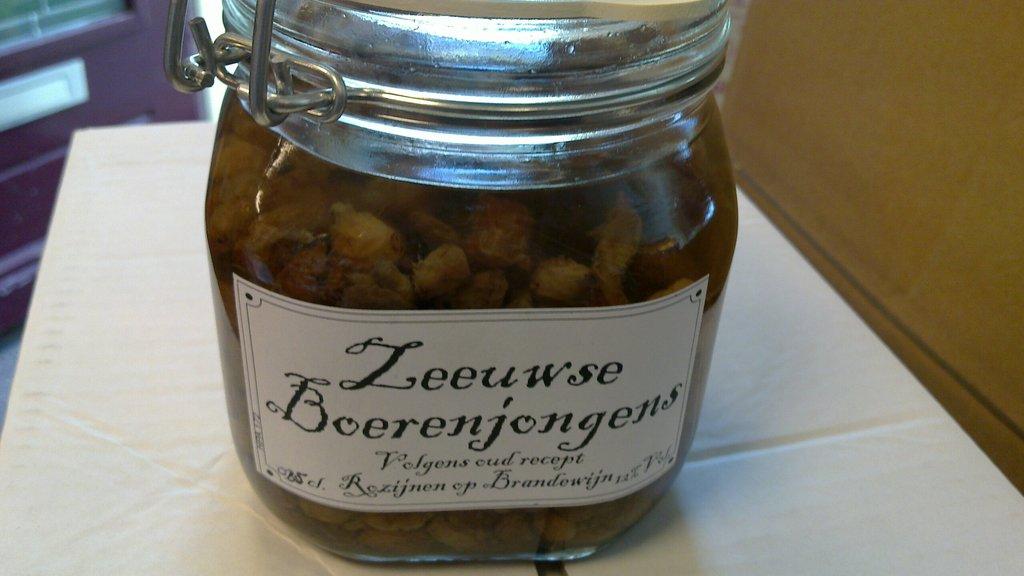What is in this jar?
Give a very brief answer. Leeuwse boerenjongens. What is in the glass?
Make the answer very short. Leeuwse boerenjongens. 